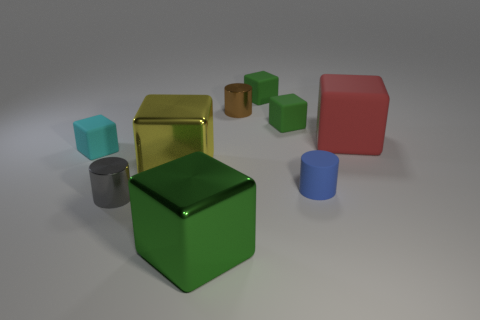What time of day or lighting conditions does the image suggest? The lighting in the image seems soft and diffused, with no harsh shadows or bright highlights. This would suggest an overcast day or a setting with ambient lighting, such as a room lit by soft box lights or indirect daylight, as often used in photography to create a gentle and even illumination on the subjects. 